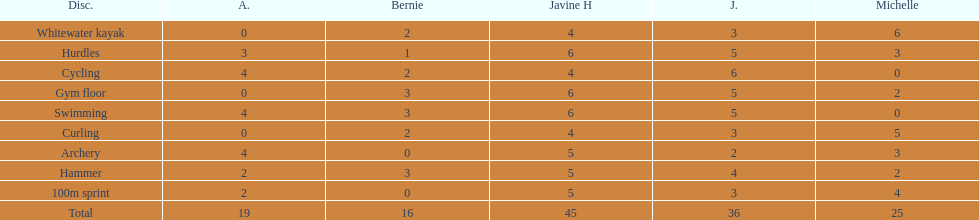Who is the quickest runner? Javine H. 